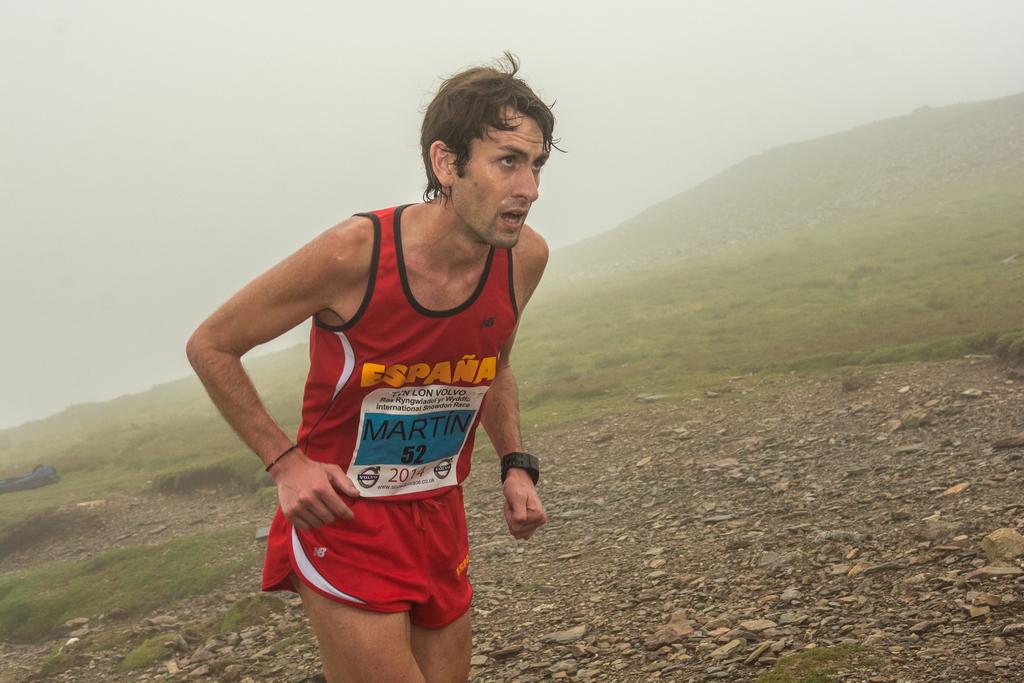What year is the runner competing in?
Ensure brevity in your answer.  2014. What is the runner's number?
Provide a succinct answer. 52. 